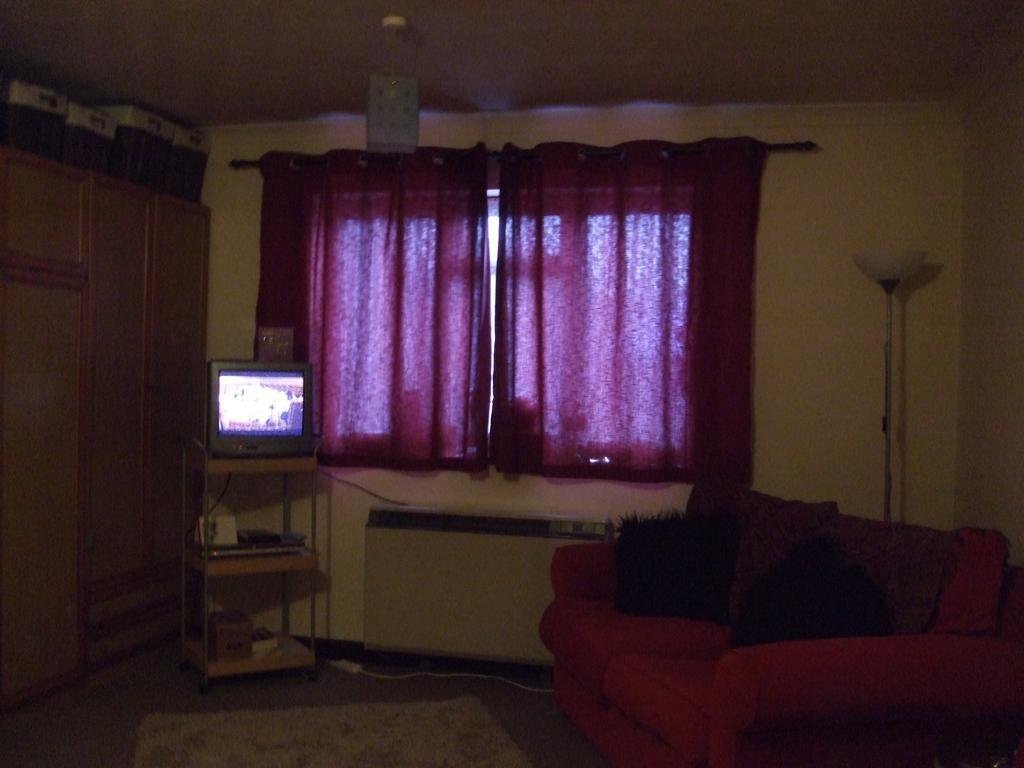Can you describe this image briefly? In this image there is a sofa in the bottom right corner of this image. There is a wall in the background. There is a window curtain in the middle of this image. There is a television on the table as we can see on the left side to this curtains. There is an object on the top of this image. There is a lamp rod on the right side of this image. There is a floor in the bottom of this image. 